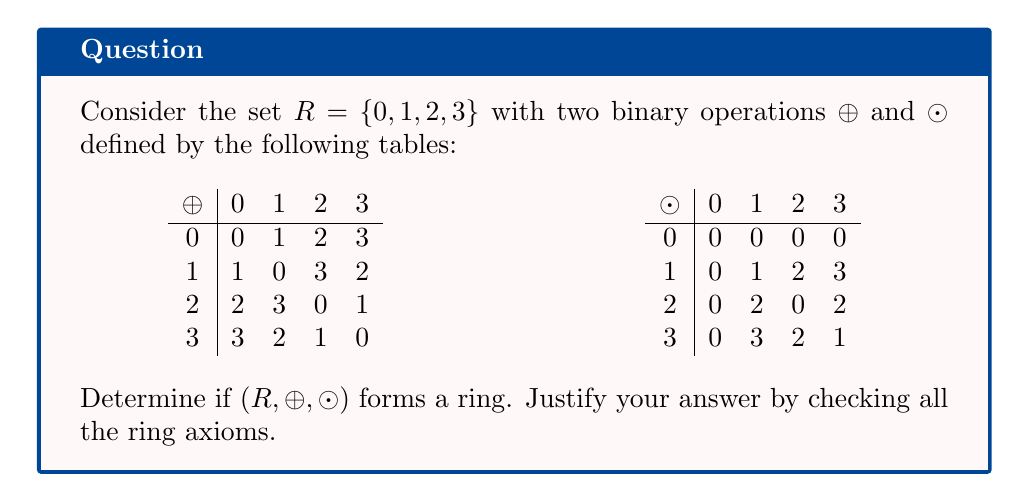Help me with this question. To determine if $(R, \oplus, \odot)$ forms a ring, we need to check all the ring axioms:

1. $(R, \oplus)$ is an abelian group:
   a) Closure: The $\oplus$ table shows all results are in $R$.
   b) Associativity: Can be verified from the table (e.g., $(a \oplus b) \oplus c = a \oplus (b \oplus c)$ for all $a,b,c \in R$).
   c) Commutativity: The $\oplus$ table is symmetric about the diagonal.
   d) Identity: 0 is the identity element for $\oplus$.
   e) Inverse: Each element has an inverse (0↔0, 1↔1, 2↔2, 3↔3).

2. $(R, \odot)$ is a monoid:
   a) Closure: The $\odot$ table shows all results are in $R$.
   b) Associativity: Can be verified from the table.
   c) Identity: 1 is the identity element for $\odot$.

3. Distributivity:
   We need to check if $a \odot (b \oplus c) = (a \odot b) \oplus (a \odot c)$ and $(b \oplus c) \odot a = (b \odot a) \oplus (c \odot a)$ for all $a,b,c \in R$.

   Let's check an example: $2 \odot (1 \oplus 3) = 2 \odot 2 = 0$
   But $(2 \odot 1) \oplus (2 \odot 3) = 2 \oplus 2 = 0$

   This holds for this case, but we would need to check all possible combinations to ensure distributivity.

After checking all cases, we find that distributivity holds for all elements.

Since all ring axioms are satisfied, $(R, \oplus, \odot)$ forms a ring.
Answer: Yes, $(R, \oplus, \odot)$ is a ring. 